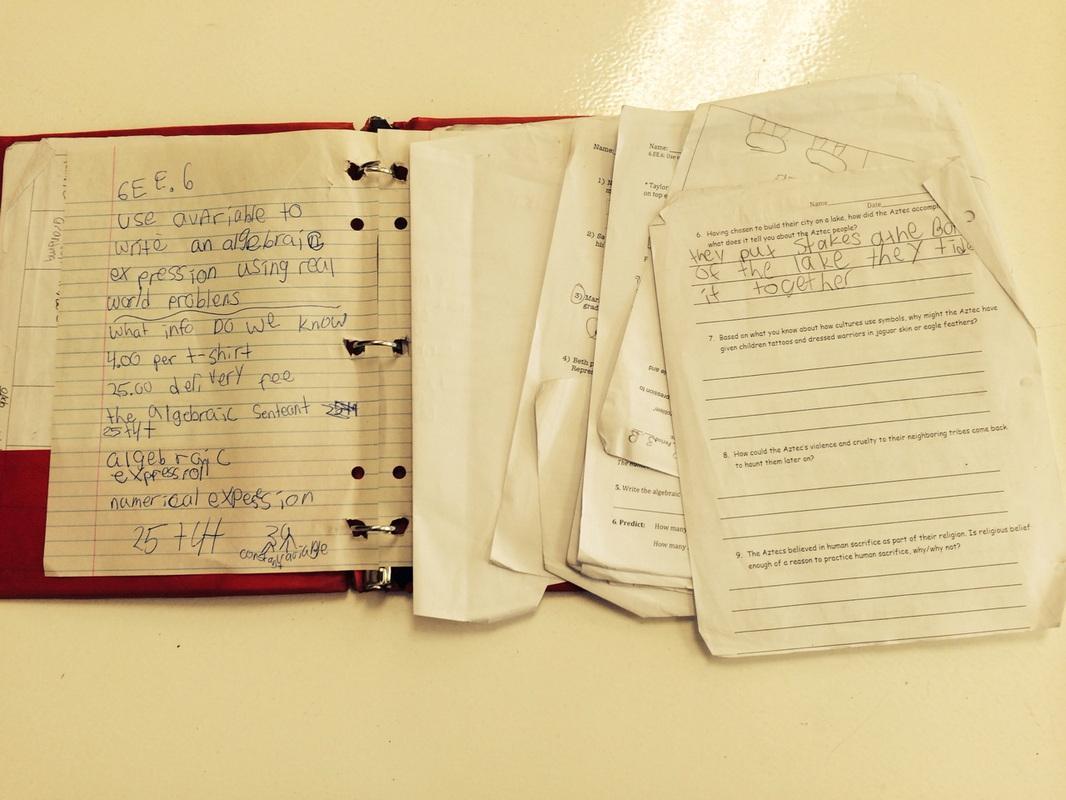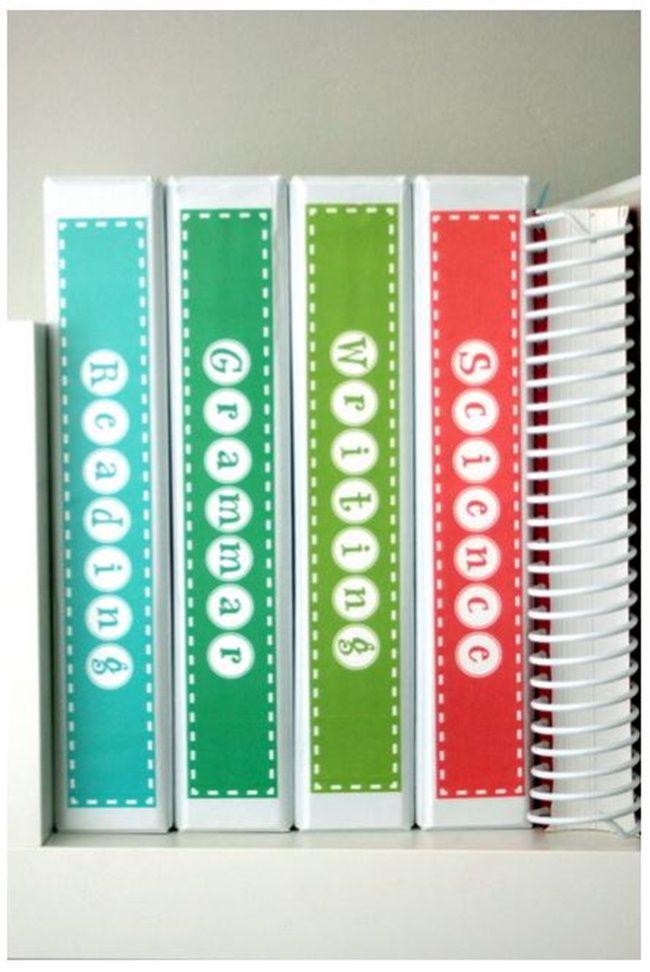The first image is the image on the left, the second image is the image on the right. Evaluate the accuracy of this statement regarding the images: "The image to the right displays an open binder, and not just a notebook.". Is it true? Answer yes or no. No. The first image is the image on the left, the second image is the image on the right. Analyze the images presented: Is the assertion "An image shows a binder with three metal rings lying open and completely flat on a surface, containing pages that aren't in the rings." valid? Answer yes or no. Yes. 